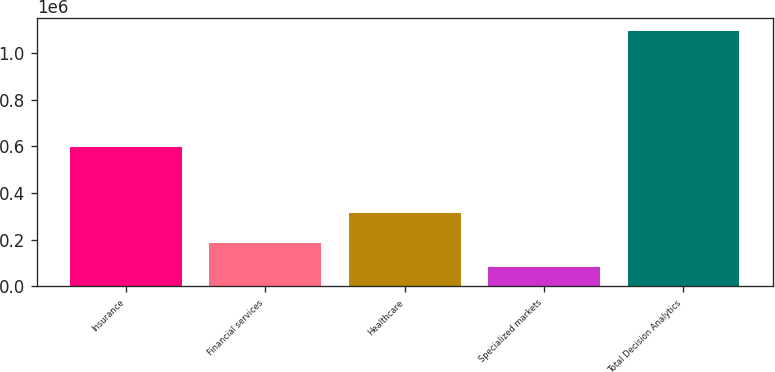<chart> <loc_0><loc_0><loc_500><loc_500><bar_chart><fcel>Insurance<fcel>Financial services<fcel>Healthcare<fcel>Specialized markets<fcel>Total Decision Analytics<nl><fcel>598757<fcel>186041<fcel>315628<fcel>84926<fcel>1.09607e+06<nl></chart> 